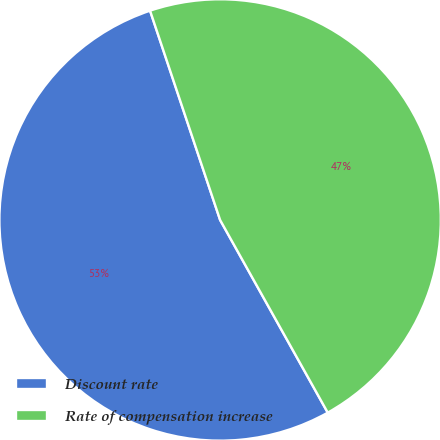Convert chart. <chart><loc_0><loc_0><loc_500><loc_500><pie_chart><fcel>Discount rate<fcel>Rate of compensation increase<nl><fcel>52.97%<fcel>47.03%<nl></chart> 